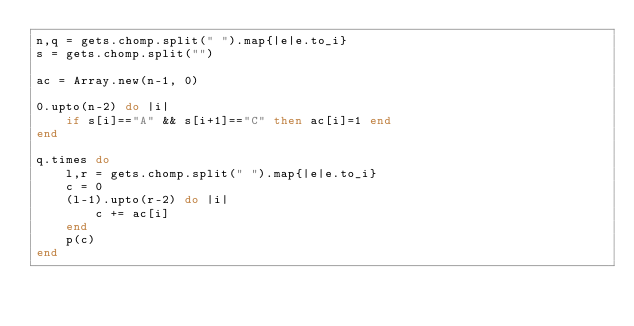<code> <loc_0><loc_0><loc_500><loc_500><_Ruby_>n,q = gets.chomp.split(" ").map{|e|e.to_i}
s = gets.chomp.split("")

ac = Array.new(n-1, 0)

0.upto(n-2) do |i|
	if s[i]=="A" && s[i+1]=="C" then ac[i]=1 end
end

q.times do
	l,r = gets.chomp.split(" ").map{|e|e.to_i}
	c = 0
	(l-1).upto(r-2) do |i|
		c += ac[i]
	end
	p(c)
end</code> 